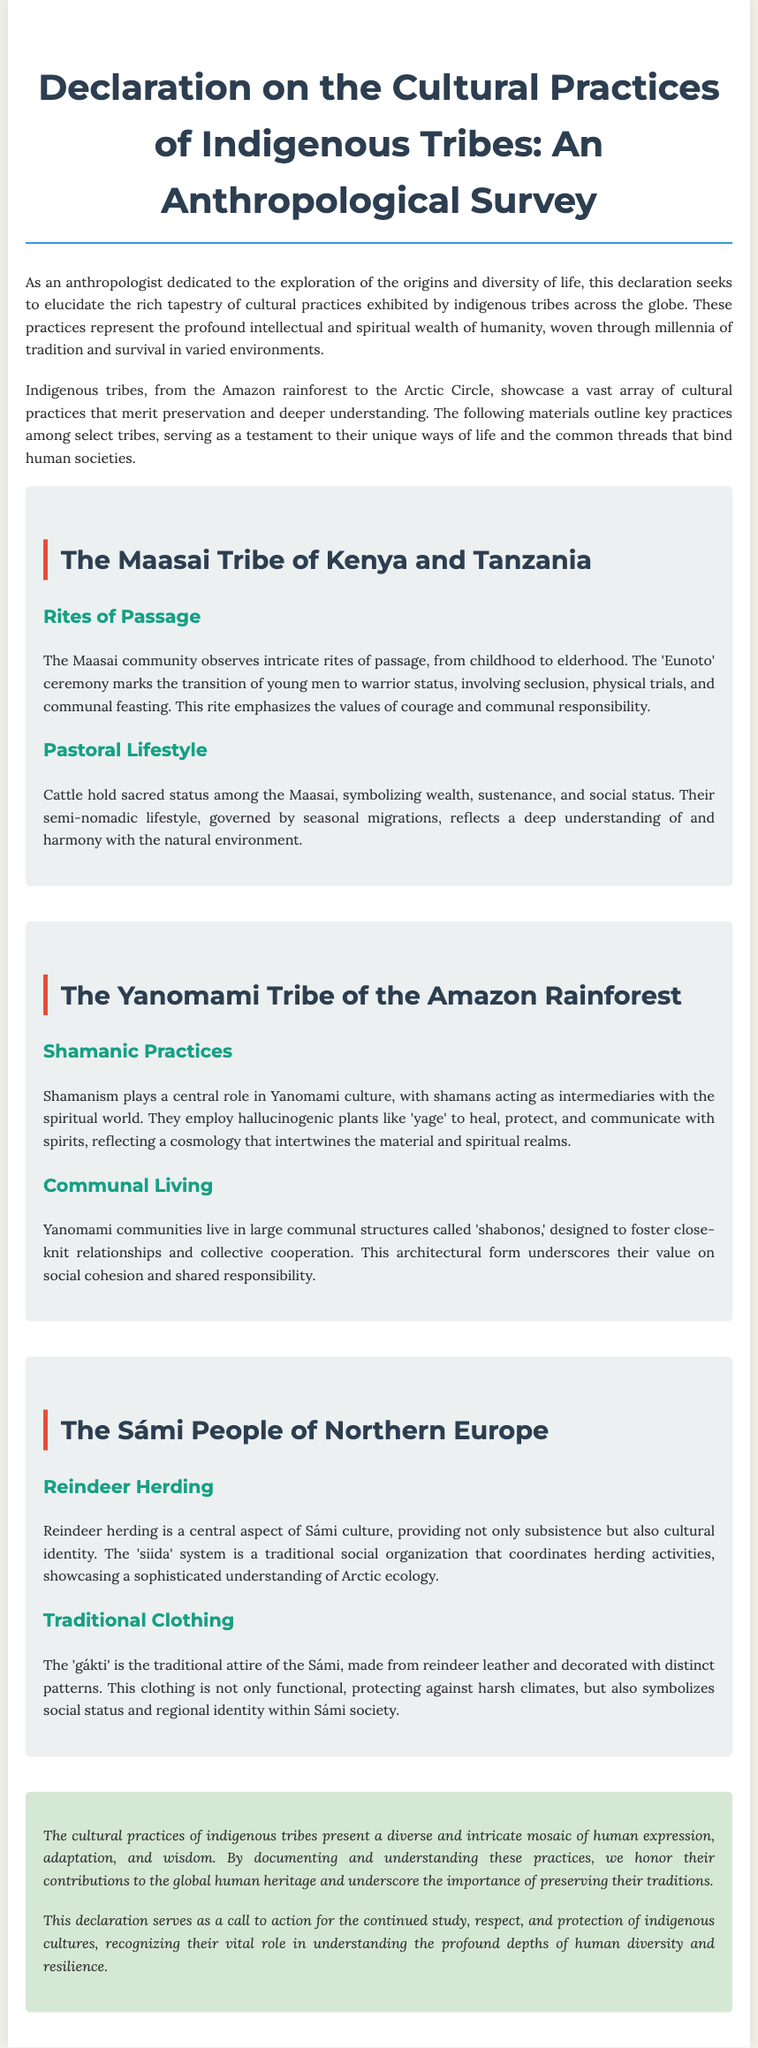what is the title of the document? The title is prominently displayed at the top of the document, giving the main focus of the content.
Answer: Declaration on the Cultural Practices of Indigenous Tribes: An Anthropological Survey how many tribes are highlighted in the document? The document discusses three distinct tribes, each with its cultural practices described.
Answer: Three what ceremony marks the transition of young men in the Maasai tribe? The document specifically mentions a rite of passage ceremony for young men in the Maasai community that highlights their cultural practices.
Answer: Eunoto what is the traditional attire called for the Sámi people? The document describes the specific clothing worn by the Sámi, emphasizing its cultural significance.
Answer: gákti what role do shamans play in Yanomami culture? The document outlines the importance of shamans in Yanomami society and their functions.
Answer: Intermediaries with the spiritual world what symbolizes wealth and status among the Maasai? The document indicates an item of significant cultural value to the Maasai tribe that represents their social structure.
Answer: Cattle what is the traditional social organization system of the Sámi people called? The document mentions a specific organizational system that governs herding activities among the Sámi.
Answer: siida why is the study of indigenous cultures significant according to the conclusion? The conclusion points out the underlying rationale for preserving and understanding indigenous practices and their contributions.
Answer: Global human heritage what is the overall theme of the document? The document emphasizes the exploration and understanding of cultural diversity and practices among different indigenous tribes.
Answer: Cultural Practices of Indigenous Tribes 